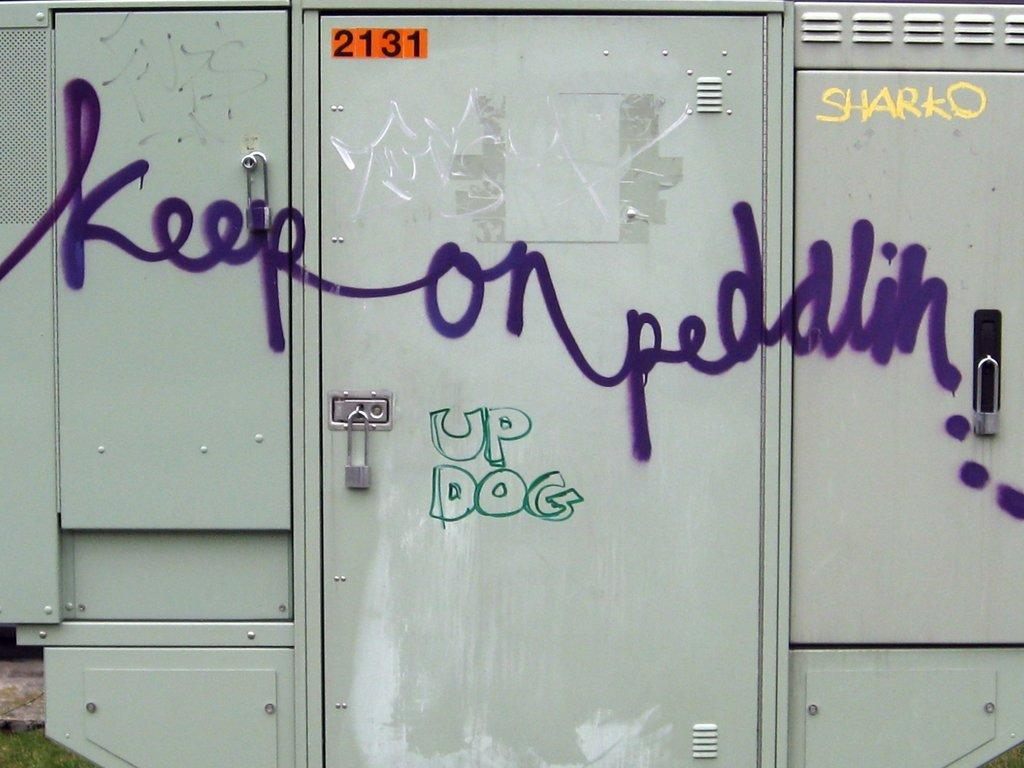What type of storage units are in the image? There are lockers in the image. What color are the lockers? The lockers are in ash color. Is there any text or markings on the lockers? Yes, there is writing on the lockers. What can be seen in the background of the image? There is grass and a rock in the background of the image. How many clocks are hanging on the lockers in the image? There are no clocks visible on the lockers in the image. 